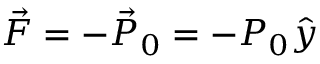Convert formula to latex. <formula><loc_0><loc_0><loc_500><loc_500>\vec { F } = - \vec { P } _ { 0 } = - P _ { 0 } \hat { y }</formula> 